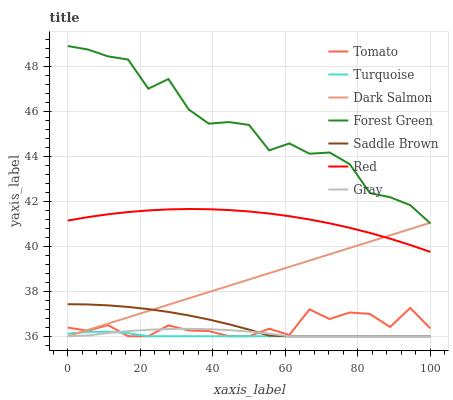Does Turquoise have the minimum area under the curve?
Answer yes or no. Yes. Does Forest Green have the maximum area under the curve?
Answer yes or no. Yes. Does Gray have the minimum area under the curve?
Answer yes or no. No. Does Gray have the maximum area under the curve?
Answer yes or no. No. Is Dark Salmon the smoothest?
Answer yes or no. Yes. Is Forest Green the roughest?
Answer yes or no. Yes. Is Gray the smoothest?
Answer yes or no. No. Is Gray the roughest?
Answer yes or no. No. Does Tomato have the lowest value?
Answer yes or no. Yes. Does Forest Green have the lowest value?
Answer yes or no. No. Does Forest Green have the highest value?
Answer yes or no. Yes. Does Gray have the highest value?
Answer yes or no. No. Is Gray less than Red?
Answer yes or no. Yes. Is Forest Green greater than Turquoise?
Answer yes or no. Yes. Does Gray intersect Saddle Brown?
Answer yes or no. Yes. Is Gray less than Saddle Brown?
Answer yes or no. No. Is Gray greater than Saddle Brown?
Answer yes or no. No. Does Gray intersect Red?
Answer yes or no. No. 